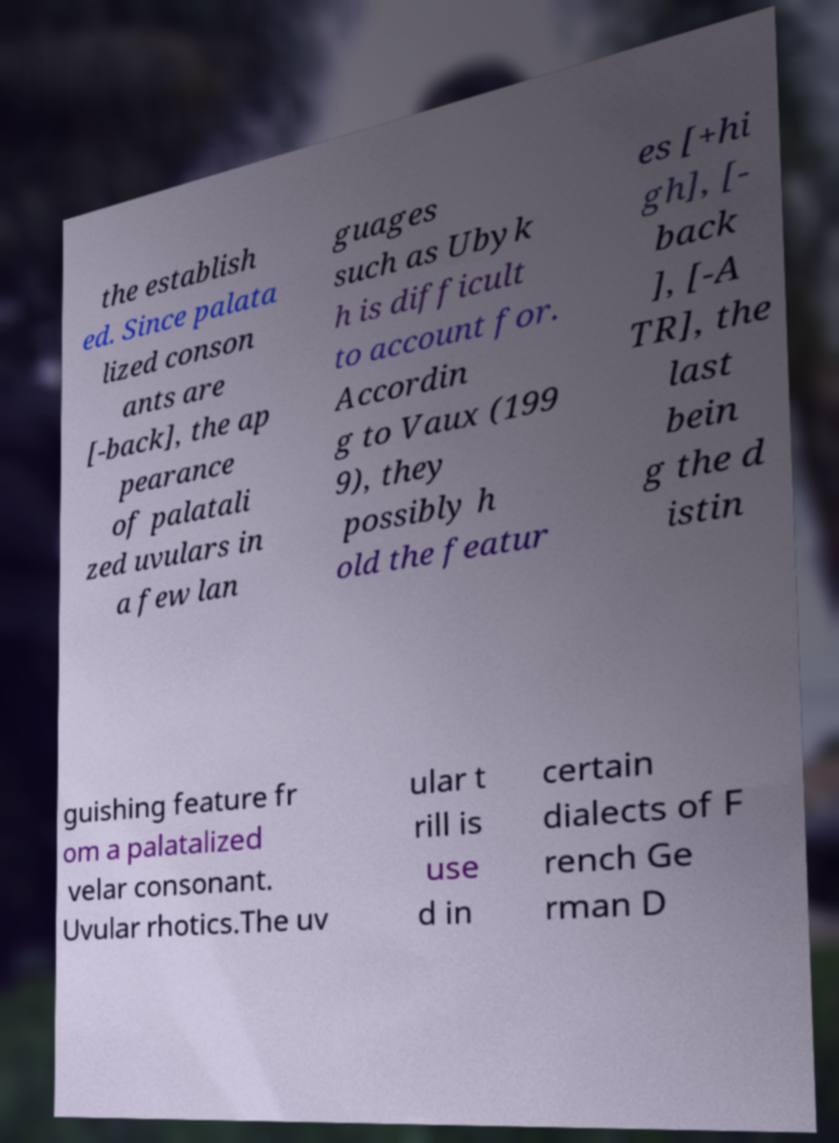I need the written content from this picture converted into text. Can you do that? the establish ed. Since palata lized conson ants are [-back], the ap pearance of palatali zed uvulars in a few lan guages such as Ubyk h is difficult to account for. Accordin g to Vaux (199 9), they possibly h old the featur es [+hi gh], [- back ], [-A TR], the last bein g the d istin guishing feature fr om a palatalized velar consonant. Uvular rhotics.The uv ular t rill is use d in certain dialects of F rench Ge rman D 